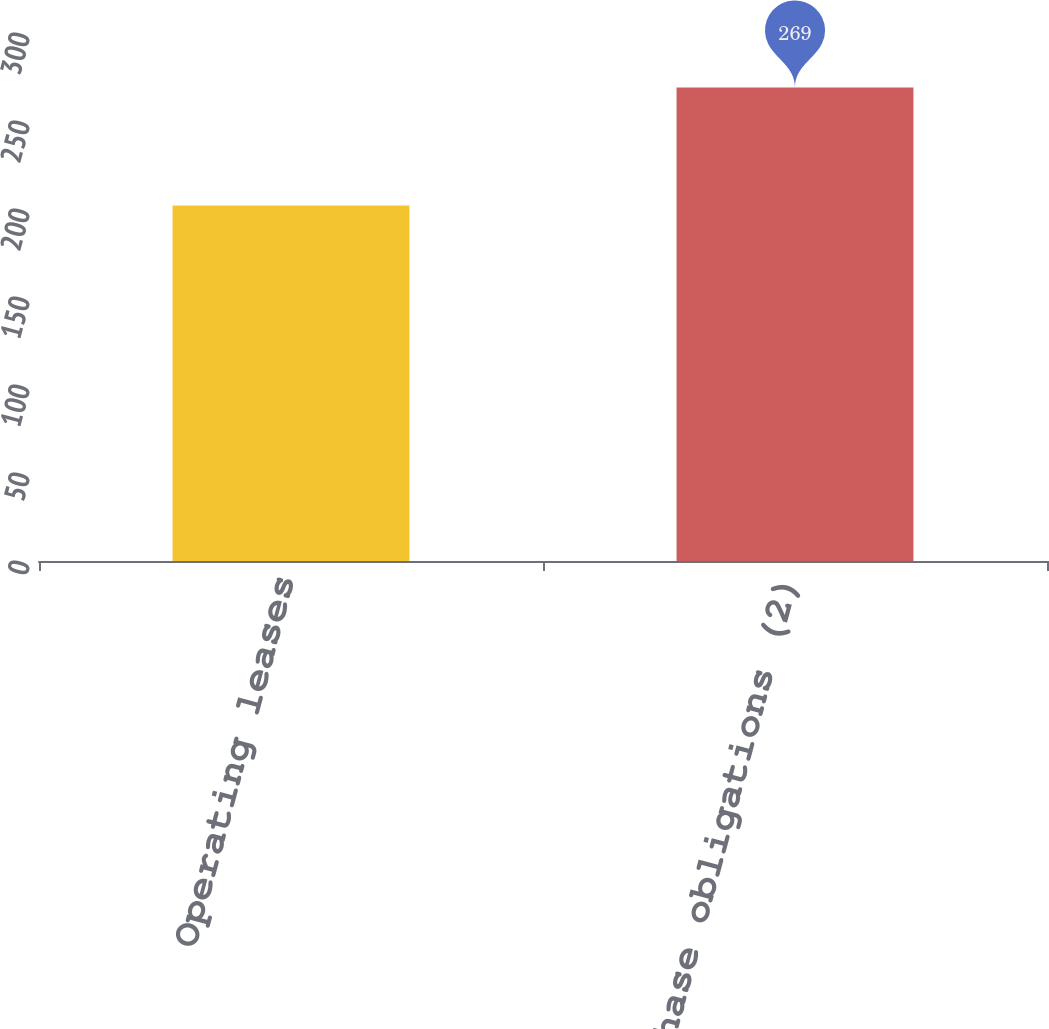<chart> <loc_0><loc_0><loc_500><loc_500><bar_chart><fcel>Operating leases<fcel>Purchase obligations (2)<nl><fcel>202<fcel>269<nl></chart> 